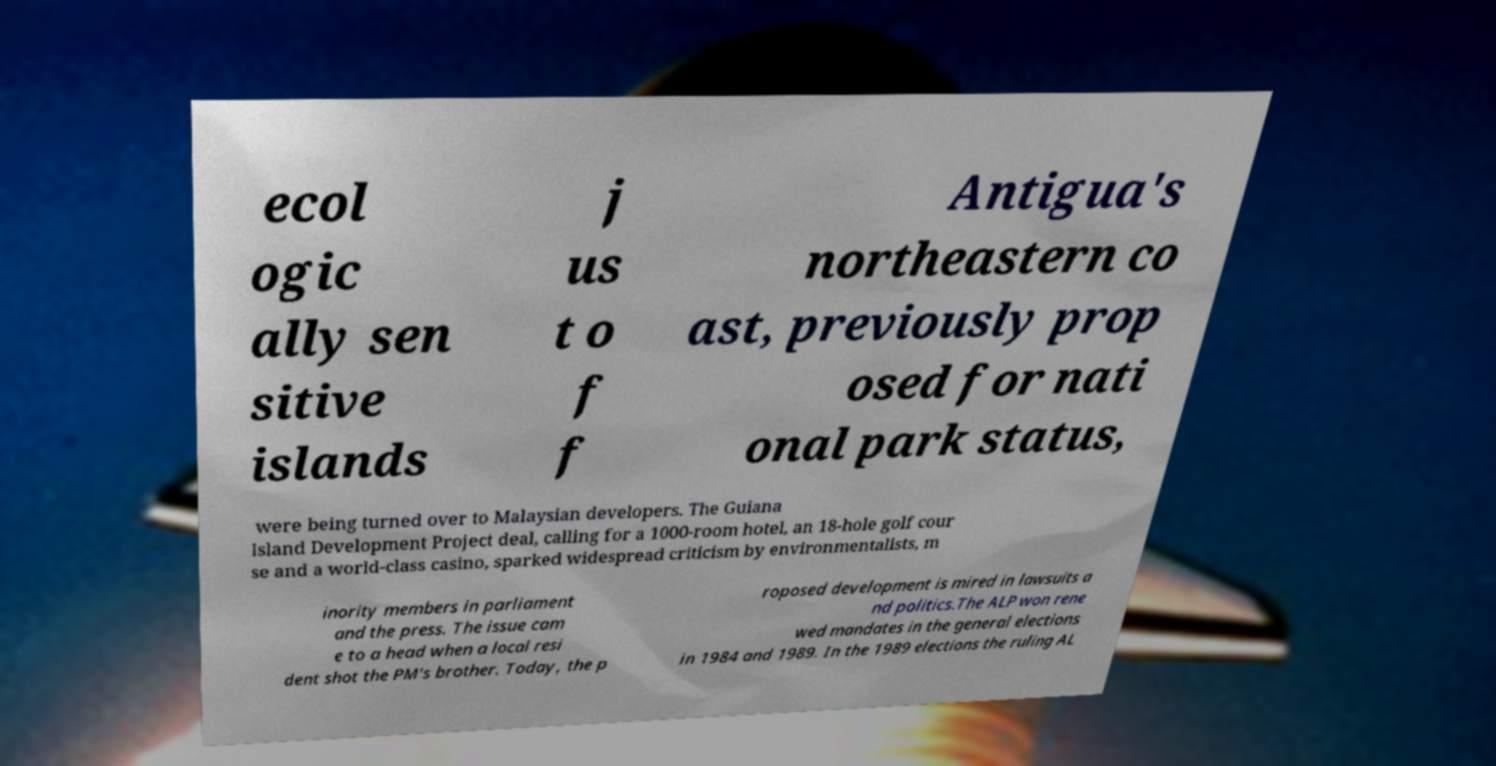Could you assist in decoding the text presented in this image and type it out clearly? ecol ogic ally sen sitive islands j us t o f f Antigua's northeastern co ast, previously prop osed for nati onal park status, were being turned over to Malaysian developers. The Guiana Island Development Project deal, calling for a 1000-room hotel, an 18-hole golf cour se and a world-class casino, sparked widespread criticism by environmentalists, m inority members in parliament and the press. The issue cam e to a head when a local resi dent shot the PM's brother. Today, the p roposed development is mired in lawsuits a nd politics.The ALP won rene wed mandates in the general elections in 1984 and 1989. In the 1989 elections the ruling AL 